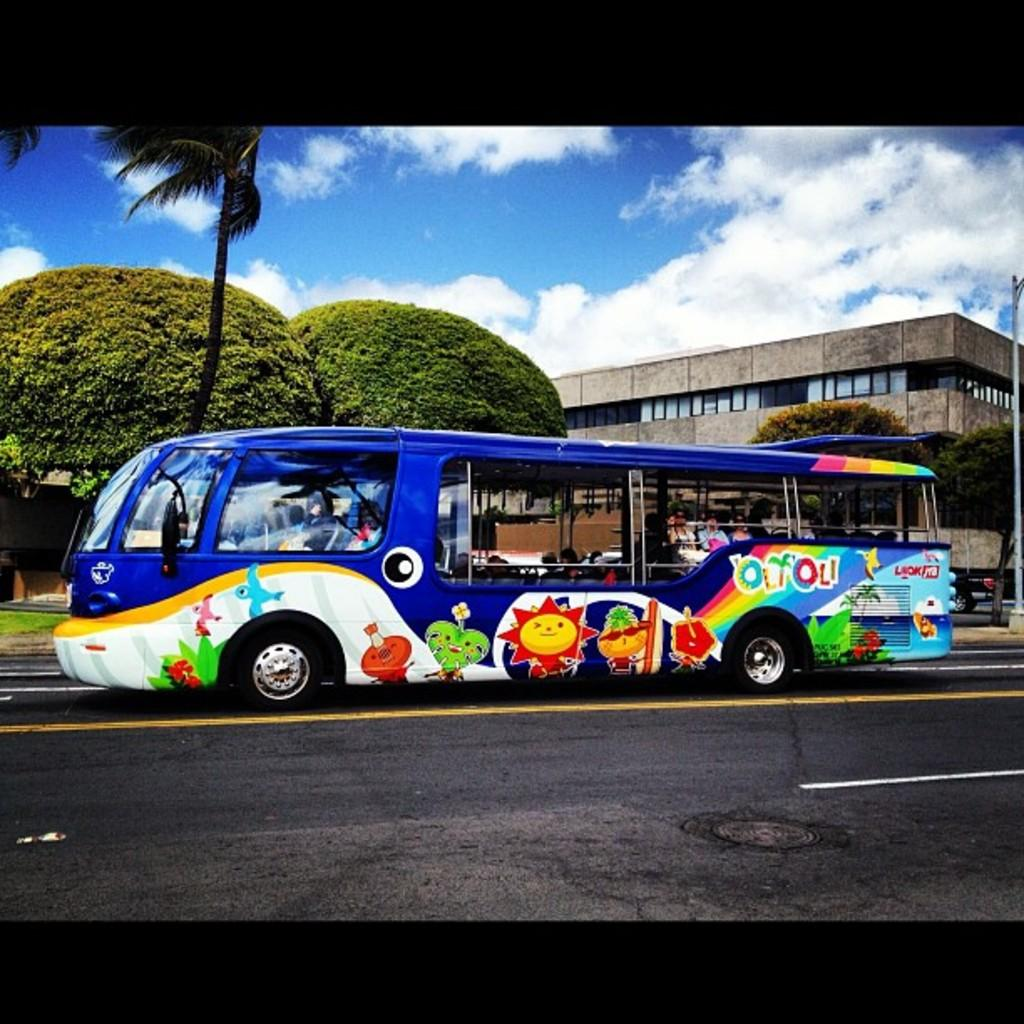<image>
Render a clear and concise summary of the photo. A colorful bus that says "OliOli" on the side is driving through a tropical area. 